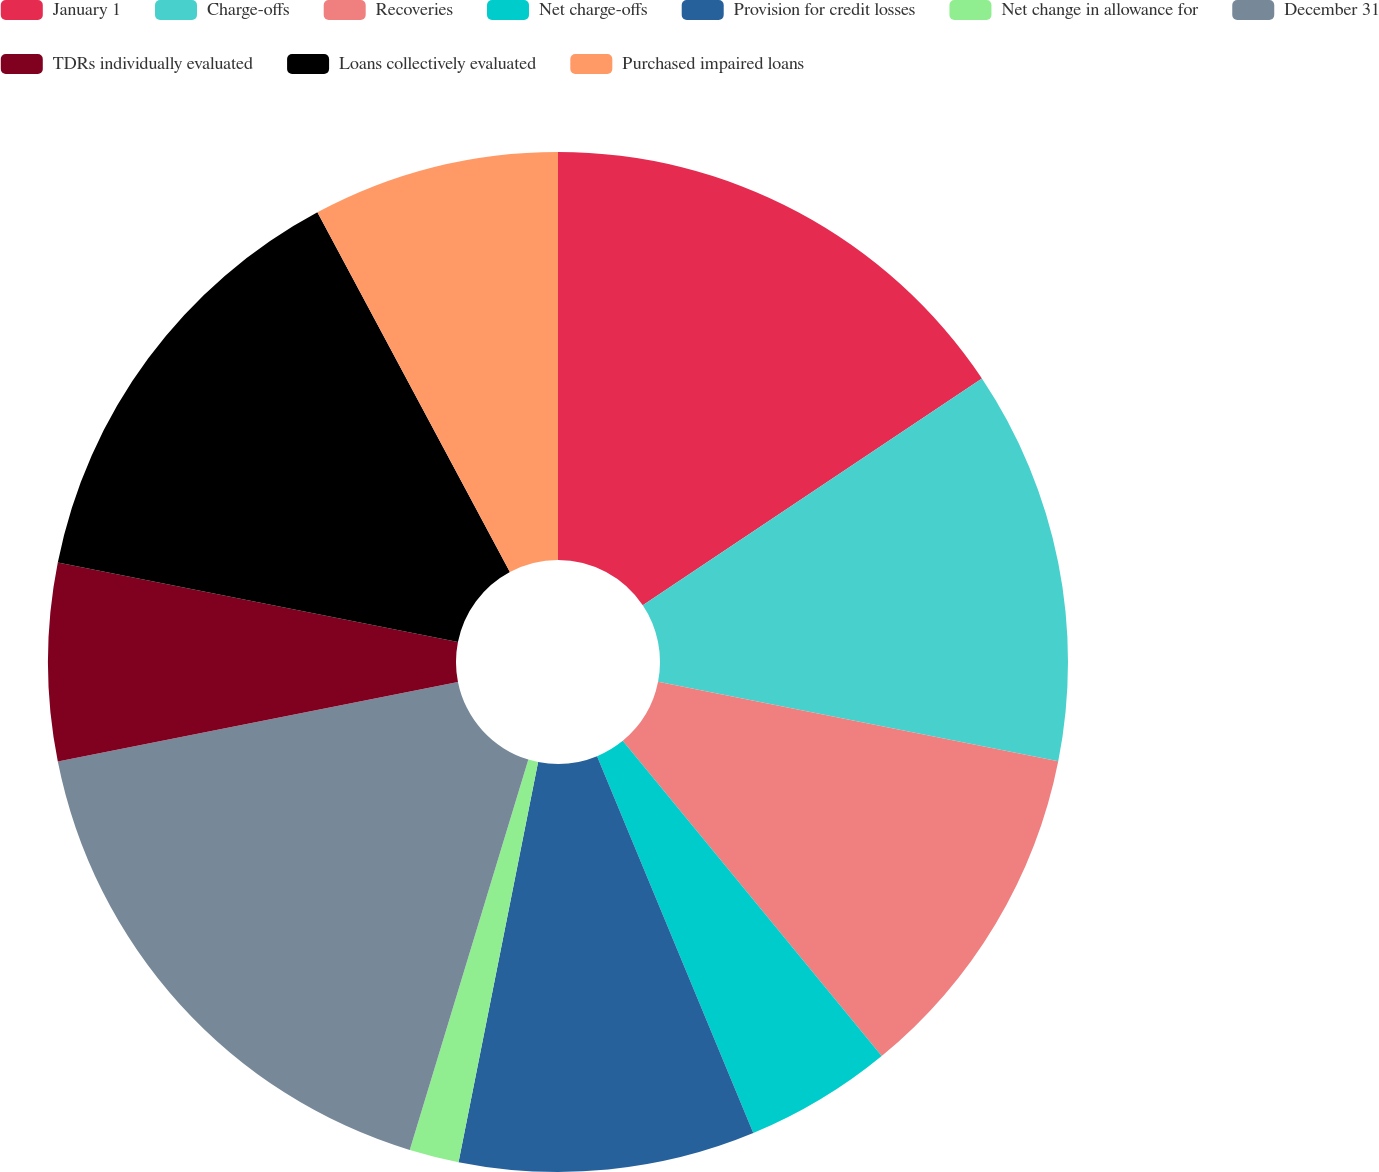<chart> <loc_0><loc_0><loc_500><loc_500><pie_chart><fcel>January 1<fcel>Charge-offs<fcel>Recoveries<fcel>Net charge-offs<fcel>Provision for credit losses<fcel>Net change in allowance for<fcel>December 31<fcel>TDRs individually evaluated<fcel>Loans collectively evaluated<fcel>Purchased impaired loans<nl><fcel>15.62%<fcel>12.5%<fcel>10.94%<fcel>4.69%<fcel>9.38%<fcel>1.57%<fcel>17.18%<fcel>6.25%<fcel>14.06%<fcel>7.82%<nl></chart> 